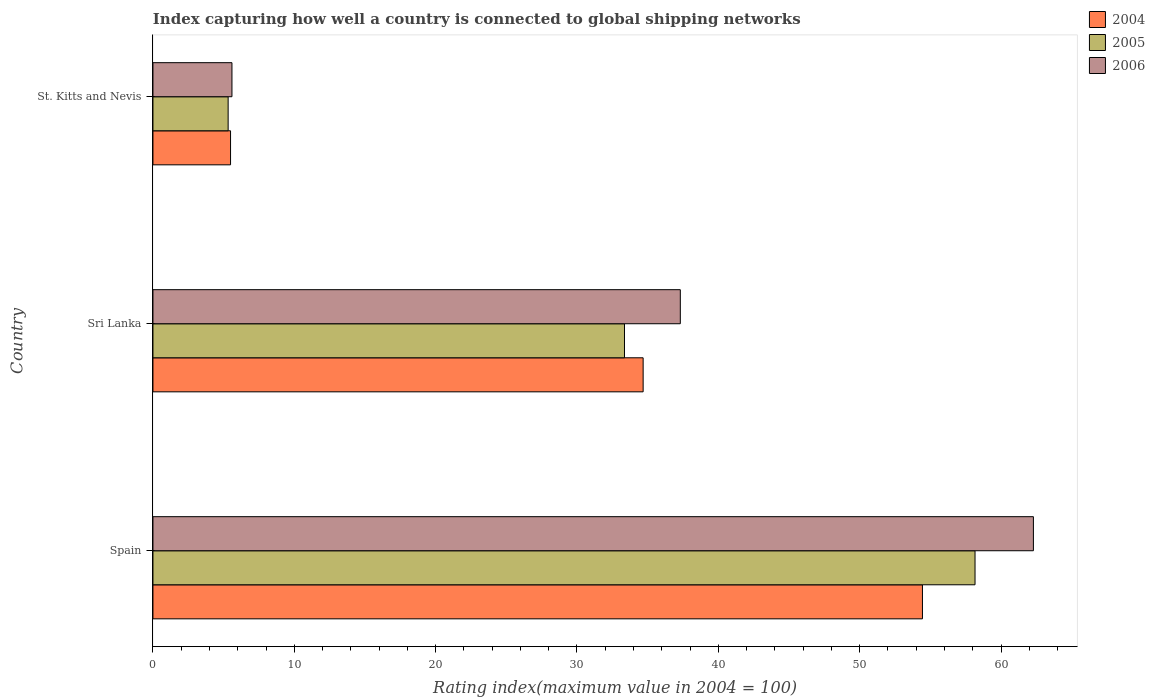How many different coloured bars are there?
Ensure brevity in your answer.  3. How many groups of bars are there?
Your answer should be very brief. 3. What is the label of the 1st group of bars from the top?
Make the answer very short. St. Kitts and Nevis. In how many cases, is the number of bars for a given country not equal to the number of legend labels?
Your answer should be compact. 0. What is the rating index in 2004 in Sri Lanka?
Give a very brief answer. 34.68. Across all countries, what is the maximum rating index in 2004?
Offer a terse response. 54.44. Across all countries, what is the minimum rating index in 2004?
Your response must be concise. 5.49. In which country was the rating index in 2004 maximum?
Your answer should be very brief. Spain. In which country was the rating index in 2006 minimum?
Your response must be concise. St. Kitts and Nevis. What is the total rating index in 2005 in the graph?
Provide a short and direct response. 96.84. What is the difference between the rating index in 2004 in Spain and that in St. Kitts and Nevis?
Offer a terse response. 48.95. What is the difference between the rating index in 2004 in Sri Lanka and the rating index in 2006 in Spain?
Make the answer very short. -27.61. What is the average rating index in 2004 per country?
Ensure brevity in your answer.  31.54. What is the difference between the rating index in 2004 and rating index in 2006 in Sri Lanka?
Make the answer very short. -2.63. What is the ratio of the rating index in 2006 in Sri Lanka to that in St. Kitts and Nevis?
Your answer should be compact. 6.67. What is the difference between the highest and the second highest rating index in 2006?
Make the answer very short. 24.98. What is the difference between the highest and the lowest rating index in 2004?
Offer a terse response. 48.95. What does the 3rd bar from the bottom in Spain represents?
Ensure brevity in your answer.  2006. How many bars are there?
Make the answer very short. 9. What is the difference between two consecutive major ticks on the X-axis?
Keep it short and to the point. 10. Are the values on the major ticks of X-axis written in scientific E-notation?
Keep it short and to the point. No. Where does the legend appear in the graph?
Provide a succinct answer. Top right. How many legend labels are there?
Ensure brevity in your answer.  3. What is the title of the graph?
Your answer should be very brief. Index capturing how well a country is connected to global shipping networks. What is the label or title of the X-axis?
Keep it short and to the point. Rating index(maximum value in 2004 = 100). What is the Rating index(maximum value in 2004 = 100) of 2004 in Spain?
Ensure brevity in your answer.  54.44. What is the Rating index(maximum value in 2004 = 100) of 2005 in Spain?
Provide a succinct answer. 58.16. What is the Rating index(maximum value in 2004 = 100) of 2006 in Spain?
Your answer should be compact. 62.29. What is the Rating index(maximum value in 2004 = 100) of 2004 in Sri Lanka?
Provide a short and direct response. 34.68. What is the Rating index(maximum value in 2004 = 100) of 2005 in Sri Lanka?
Keep it short and to the point. 33.36. What is the Rating index(maximum value in 2004 = 100) of 2006 in Sri Lanka?
Your response must be concise. 37.31. What is the Rating index(maximum value in 2004 = 100) in 2004 in St. Kitts and Nevis?
Provide a succinct answer. 5.49. What is the Rating index(maximum value in 2004 = 100) of 2005 in St. Kitts and Nevis?
Offer a very short reply. 5.32. What is the Rating index(maximum value in 2004 = 100) of 2006 in St. Kitts and Nevis?
Give a very brief answer. 5.59. Across all countries, what is the maximum Rating index(maximum value in 2004 = 100) of 2004?
Offer a very short reply. 54.44. Across all countries, what is the maximum Rating index(maximum value in 2004 = 100) in 2005?
Your response must be concise. 58.16. Across all countries, what is the maximum Rating index(maximum value in 2004 = 100) of 2006?
Keep it short and to the point. 62.29. Across all countries, what is the minimum Rating index(maximum value in 2004 = 100) of 2004?
Your answer should be compact. 5.49. Across all countries, what is the minimum Rating index(maximum value in 2004 = 100) of 2005?
Offer a terse response. 5.32. Across all countries, what is the minimum Rating index(maximum value in 2004 = 100) of 2006?
Keep it short and to the point. 5.59. What is the total Rating index(maximum value in 2004 = 100) in 2004 in the graph?
Keep it short and to the point. 94.61. What is the total Rating index(maximum value in 2004 = 100) of 2005 in the graph?
Give a very brief answer. 96.84. What is the total Rating index(maximum value in 2004 = 100) in 2006 in the graph?
Make the answer very short. 105.19. What is the difference between the Rating index(maximum value in 2004 = 100) in 2004 in Spain and that in Sri Lanka?
Ensure brevity in your answer.  19.76. What is the difference between the Rating index(maximum value in 2004 = 100) in 2005 in Spain and that in Sri Lanka?
Keep it short and to the point. 24.8. What is the difference between the Rating index(maximum value in 2004 = 100) in 2006 in Spain and that in Sri Lanka?
Ensure brevity in your answer.  24.98. What is the difference between the Rating index(maximum value in 2004 = 100) in 2004 in Spain and that in St. Kitts and Nevis?
Offer a very short reply. 48.95. What is the difference between the Rating index(maximum value in 2004 = 100) of 2005 in Spain and that in St. Kitts and Nevis?
Keep it short and to the point. 52.84. What is the difference between the Rating index(maximum value in 2004 = 100) of 2006 in Spain and that in St. Kitts and Nevis?
Provide a succinct answer. 56.7. What is the difference between the Rating index(maximum value in 2004 = 100) of 2004 in Sri Lanka and that in St. Kitts and Nevis?
Your answer should be compact. 29.19. What is the difference between the Rating index(maximum value in 2004 = 100) of 2005 in Sri Lanka and that in St. Kitts and Nevis?
Your answer should be very brief. 28.04. What is the difference between the Rating index(maximum value in 2004 = 100) in 2006 in Sri Lanka and that in St. Kitts and Nevis?
Keep it short and to the point. 31.72. What is the difference between the Rating index(maximum value in 2004 = 100) of 2004 in Spain and the Rating index(maximum value in 2004 = 100) of 2005 in Sri Lanka?
Keep it short and to the point. 21.08. What is the difference between the Rating index(maximum value in 2004 = 100) of 2004 in Spain and the Rating index(maximum value in 2004 = 100) of 2006 in Sri Lanka?
Offer a terse response. 17.13. What is the difference between the Rating index(maximum value in 2004 = 100) in 2005 in Spain and the Rating index(maximum value in 2004 = 100) in 2006 in Sri Lanka?
Your response must be concise. 20.85. What is the difference between the Rating index(maximum value in 2004 = 100) of 2004 in Spain and the Rating index(maximum value in 2004 = 100) of 2005 in St. Kitts and Nevis?
Your answer should be very brief. 49.12. What is the difference between the Rating index(maximum value in 2004 = 100) of 2004 in Spain and the Rating index(maximum value in 2004 = 100) of 2006 in St. Kitts and Nevis?
Your response must be concise. 48.85. What is the difference between the Rating index(maximum value in 2004 = 100) of 2005 in Spain and the Rating index(maximum value in 2004 = 100) of 2006 in St. Kitts and Nevis?
Give a very brief answer. 52.57. What is the difference between the Rating index(maximum value in 2004 = 100) in 2004 in Sri Lanka and the Rating index(maximum value in 2004 = 100) in 2005 in St. Kitts and Nevis?
Provide a short and direct response. 29.36. What is the difference between the Rating index(maximum value in 2004 = 100) in 2004 in Sri Lanka and the Rating index(maximum value in 2004 = 100) in 2006 in St. Kitts and Nevis?
Offer a terse response. 29.09. What is the difference between the Rating index(maximum value in 2004 = 100) of 2005 in Sri Lanka and the Rating index(maximum value in 2004 = 100) of 2006 in St. Kitts and Nevis?
Provide a succinct answer. 27.77. What is the average Rating index(maximum value in 2004 = 100) in 2004 per country?
Ensure brevity in your answer.  31.54. What is the average Rating index(maximum value in 2004 = 100) of 2005 per country?
Your answer should be compact. 32.28. What is the average Rating index(maximum value in 2004 = 100) in 2006 per country?
Keep it short and to the point. 35.06. What is the difference between the Rating index(maximum value in 2004 = 100) in 2004 and Rating index(maximum value in 2004 = 100) in 2005 in Spain?
Provide a short and direct response. -3.72. What is the difference between the Rating index(maximum value in 2004 = 100) of 2004 and Rating index(maximum value in 2004 = 100) of 2006 in Spain?
Make the answer very short. -7.85. What is the difference between the Rating index(maximum value in 2004 = 100) of 2005 and Rating index(maximum value in 2004 = 100) of 2006 in Spain?
Offer a very short reply. -4.13. What is the difference between the Rating index(maximum value in 2004 = 100) of 2004 and Rating index(maximum value in 2004 = 100) of 2005 in Sri Lanka?
Make the answer very short. 1.32. What is the difference between the Rating index(maximum value in 2004 = 100) in 2004 and Rating index(maximum value in 2004 = 100) in 2006 in Sri Lanka?
Offer a terse response. -2.63. What is the difference between the Rating index(maximum value in 2004 = 100) in 2005 and Rating index(maximum value in 2004 = 100) in 2006 in Sri Lanka?
Give a very brief answer. -3.95. What is the difference between the Rating index(maximum value in 2004 = 100) in 2004 and Rating index(maximum value in 2004 = 100) in 2005 in St. Kitts and Nevis?
Your answer should be compact. 0.17. What is the difference between the Rating index(maximum value in 2004 = 100) of 2004 and Rating index(maximum value in 2004 = 100) of 2006 in St. Kitts and Nevis?
Keep it short and to the point. -0.1. What is the difference between the Rating index(maximum value in 2004 = 100) in 2005 and Rating index(maximum value in 2004 = 100) in 2006 in St. Kitts and Nevis?
Provide a succinct answer. -0.27. What is the ratio of the Rating index(maximum value in 2004 = 100) of 2004 in Spain to that in Sri Lanka?
Ensure brevity in your answer.  1.57. What is the ratio of the Rating index(maximum value in 2004 = 100) in 2005 in Spain to that in Sri Lanka?
Your response must be concise. 1.74. What is the ratio of the Rating index(maximum value in 2004 = 100) of 2006 in Spain to that in Sri Lanka?
Your answer should be compact. 1.67. What is the ratio of the Rating index(maximum value in 2004 = 100) of 2004 in Spain to that in St. Kitts and Nevis?
Ensure brevity in your answer.  9.92. What is the ratio of the Rating index(maximum value in 2004 = 100) of 2005 in Spain to that in St. Kitts and Nevis?
Provide a succinct answer. 10.93. What is the ratio of the Rating index(maximum value in 2004 = 100) of 2006 in Spain to that in St. Kitts and Nevis?
Your answer should be very brief. 11.14. What is the ratio of the Rating index(maximum value in 2004 = 100) of 2004 in Sri Lanka to that in St. Kitts and Nevis?
Keep it short and to the point. 6.32. What is the ratio of the Rating index(maximum value in 2004 = 100) of 2005 in Sri Lanka to that in St. Kitts and Nevis?
Give a very brief answer. 6.27. What is the ratio of the Rating index(maximum value in 2004 = 100) of 2006 in Sri Lanka to that in St. Kitts and Nevis?
Ensure brevity in your answer.  6.67. What is the difference between the highest and the second highest Rating index(maximum value in 2004 = 100) in 2004?
Provide a succinct answer. 19.76. What is the difference between the highest and the second highest Rating index(maximum value in 2004 = 100) in 2005?
Offer a very short reply. 24.8. What is the difference between the highest and the second highest Rating index(maximum value in 2004 = 100) of 2006?
Give a very brief answer. 24.98. What is the difference between the highest and the lowest Rating index(maximum value in 2004 = 100) of 2004?
Ensure brevity in your answer.  48.95. What is the difference between the highest and the lowest Rating index(maximum value in 2004 = 100) of 2005?
Make the answer very short. 52.84. What is the difference between the highest and the lowest Rating index(maximum value in 2004 = 100) of 2006?
Provide a succinct answer. 56.7. 